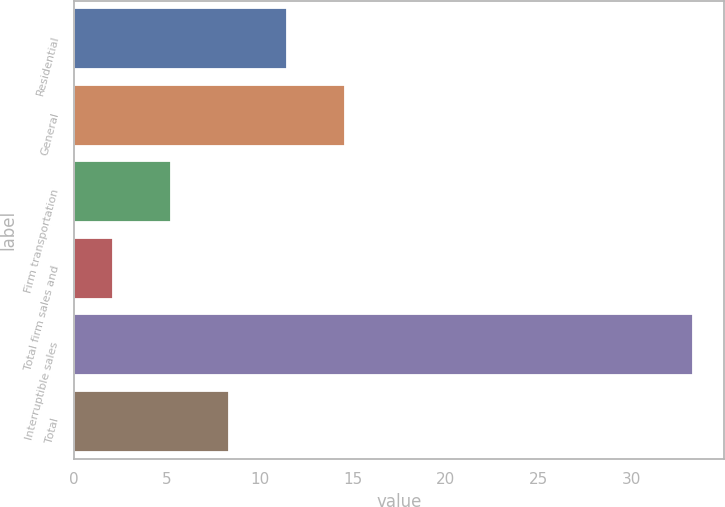Convert chart. <chart><loc_0><loc_0><loc_500><loc_500><bar_chart><fcel>Residential<fcel>General<fcel>Firm transportation<fcel>Total firm sales and<fcel>Interruptible sales<fcel>Total<nl><fcel>11.46<fcel>14.58<fcel>5.22<fcel>2.1<fcel>33.3<fcel>8.34<nl></chart> 